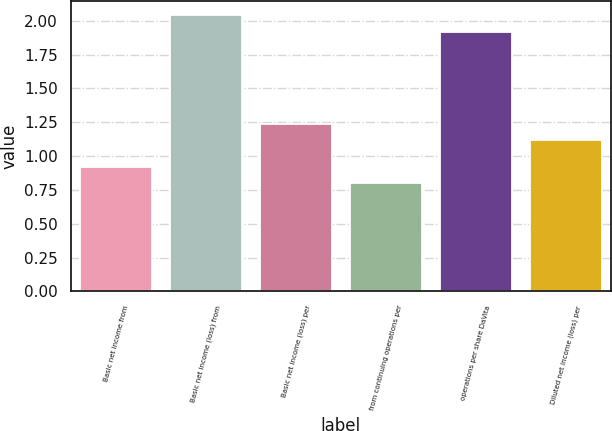Convert chart. <chart><loc_0><loc_0><loc_500><loc_500><bar_chart><fcel>Basic net income from<fcel>Basic net income (loss) from<fcel>Basic net income (loss) per<fcel>from continuing operations per<fcel>operations per share DaVita<fcel>Diluted net income (loss) per<nl><fcel>0.92<fcel>2.04<fcel>1.24<fcel>0.8<fcel>1.92<fcel>1.12<nl></chart> 